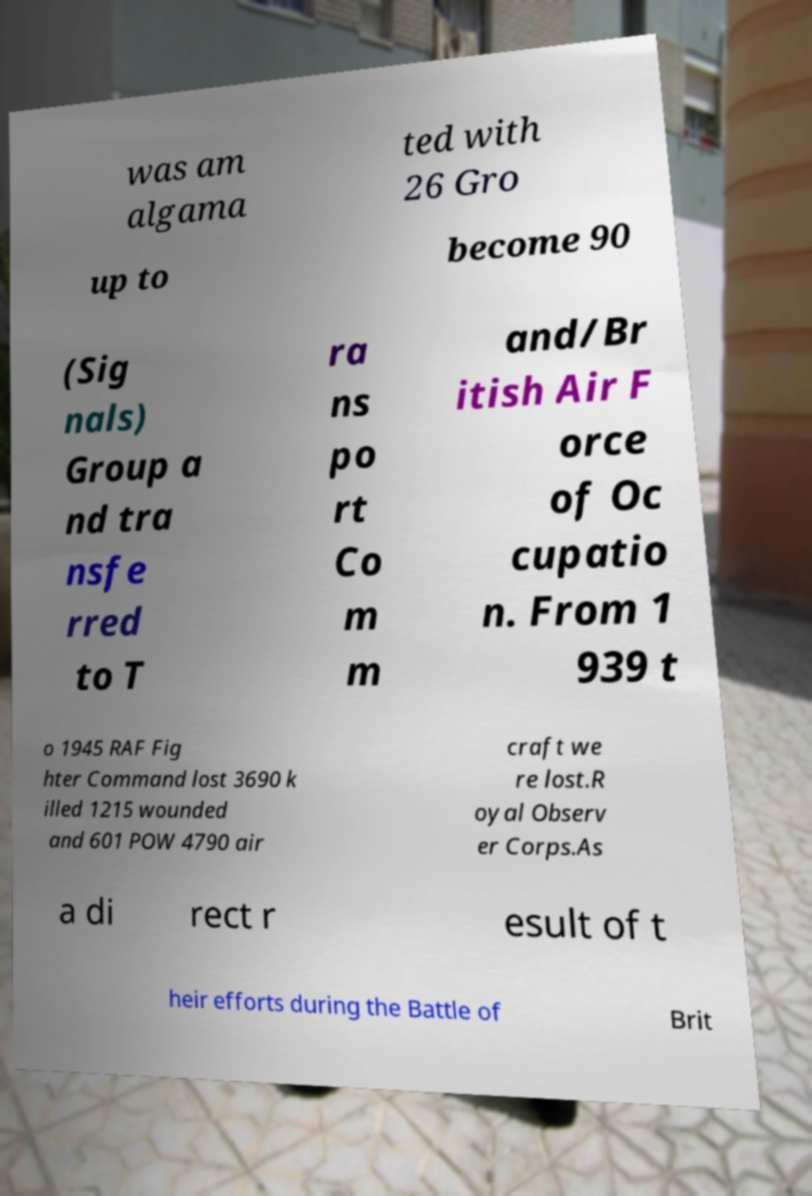What messages or text are displayed in this image? I need them in a readable, typed format. was am algama ted with 26 Gro up to become 90 (Sig nals) Group a nd tra nsfe rred to T ra ns po rt Co m m and/Br itish Air F orce of Oc cupatio n. From 1 939 t o 1945 RAF Fig hter Command lost 3690 k illed 1215 wounded and 601 POW 4790 air craft we re lost.R oyal Observ er Corps.As a di rect r esult of t heir efforts during the Battle of Brit 